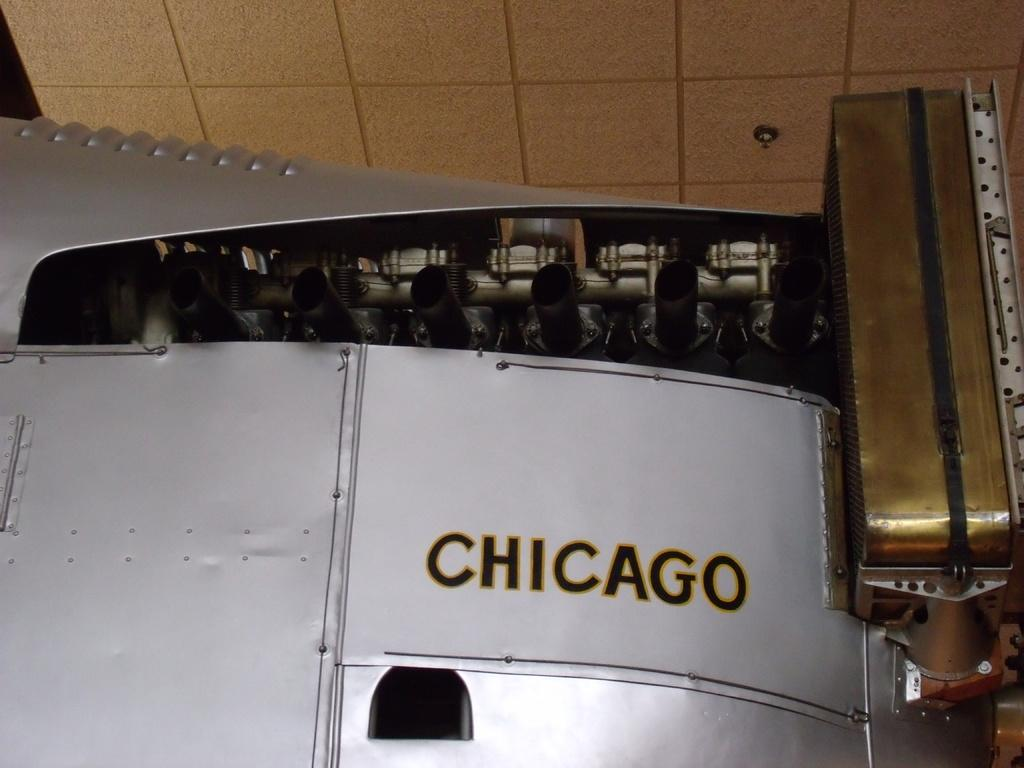<image>
Write a terse but informative summary of the picture. A large, silver piece of machinery is printed with the word Chicago. 